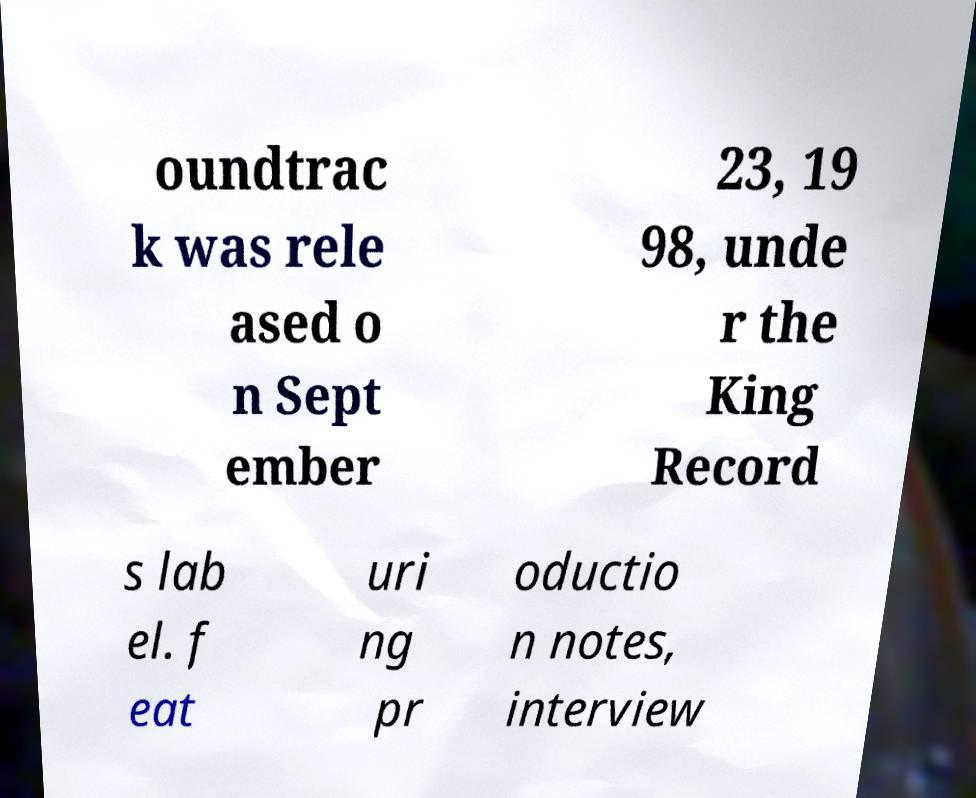Can you accurately transcribe the text from the provided image for me? oundtrac k was rele ased o n Sept ember 23, 19 98, unde r the King Record s lab el. f eat uri ng pr oductio n notes, interview 